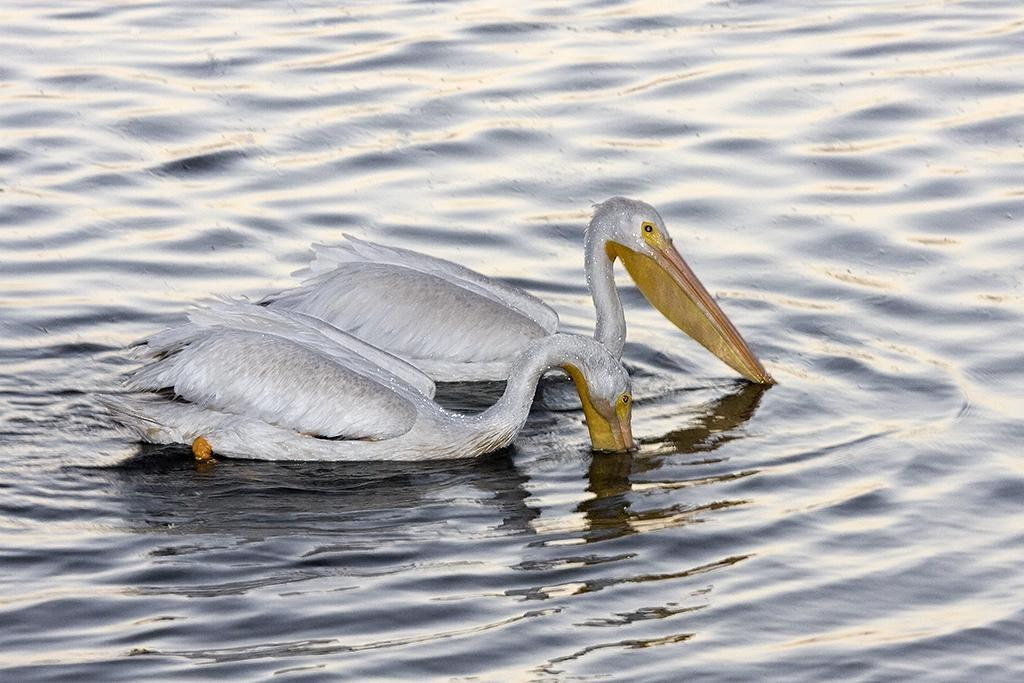What animals are in the center of the image? There are two birds in the center of the image. What is visible at the bottom of the image? There is water visible at the bottom of the image. What type of calculator can be seen floating in the water in the image? There is no calculator present in the image; it features two birds and water. 